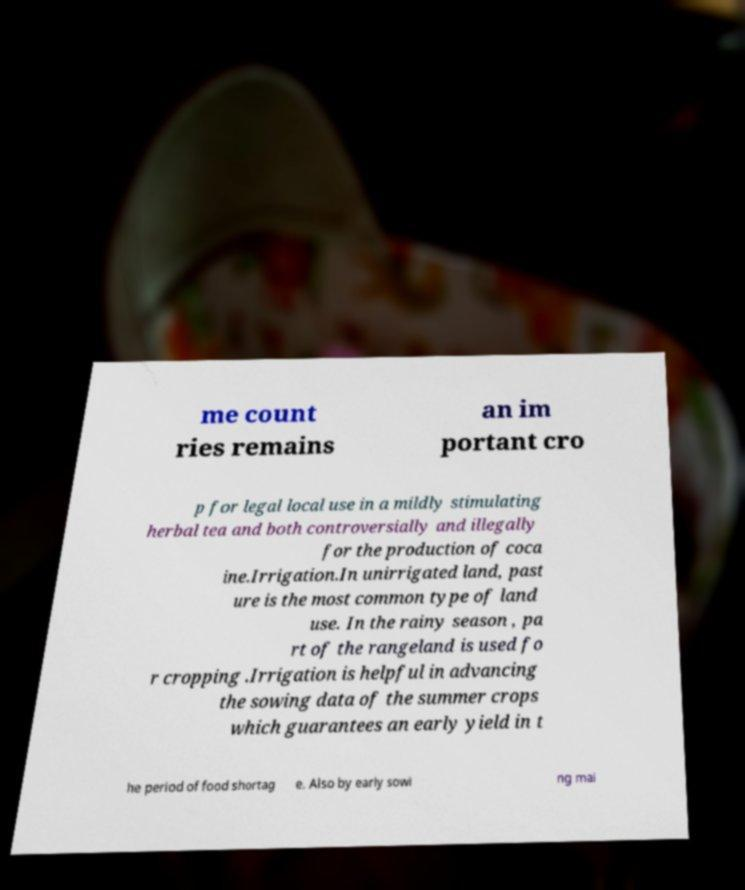I need the written content from this picture converted into text. Can you do that? me count ries remains an im portant cro p for legal local use in a mildly stimulating herbal tea and both controversially and illegally for the production of coca ine.Irrigation.In unirrigated land, past ure is the most common type of land use. In the rainy season , pa rt of the rangeland is used fo r cropping .Irrigation is helpful in advancing the sowing data of the summer crops which guarantees an early yield in t he period of food shortag e. Also by early sowi ng mai 